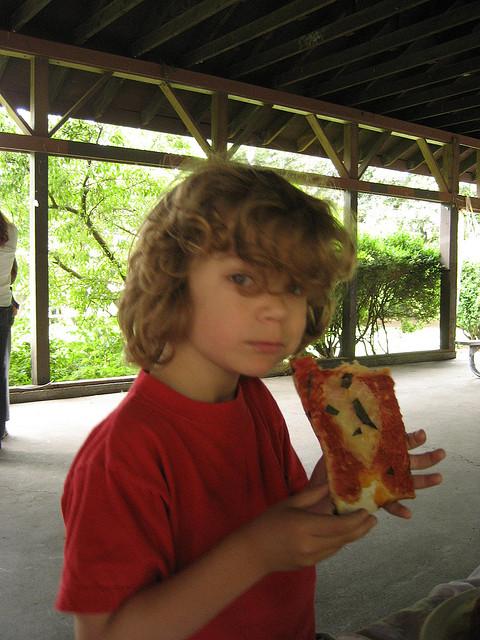What is the child eating?
Answer briefly. Pizza. What will keep any rain off this child?
Keep it brief. Roof. What gender is this child?
Answer briefly. Male. How many people are wearing stripes?
Keep it brief. 0. What is the kid eating?
Quick response, please. Pizza. 